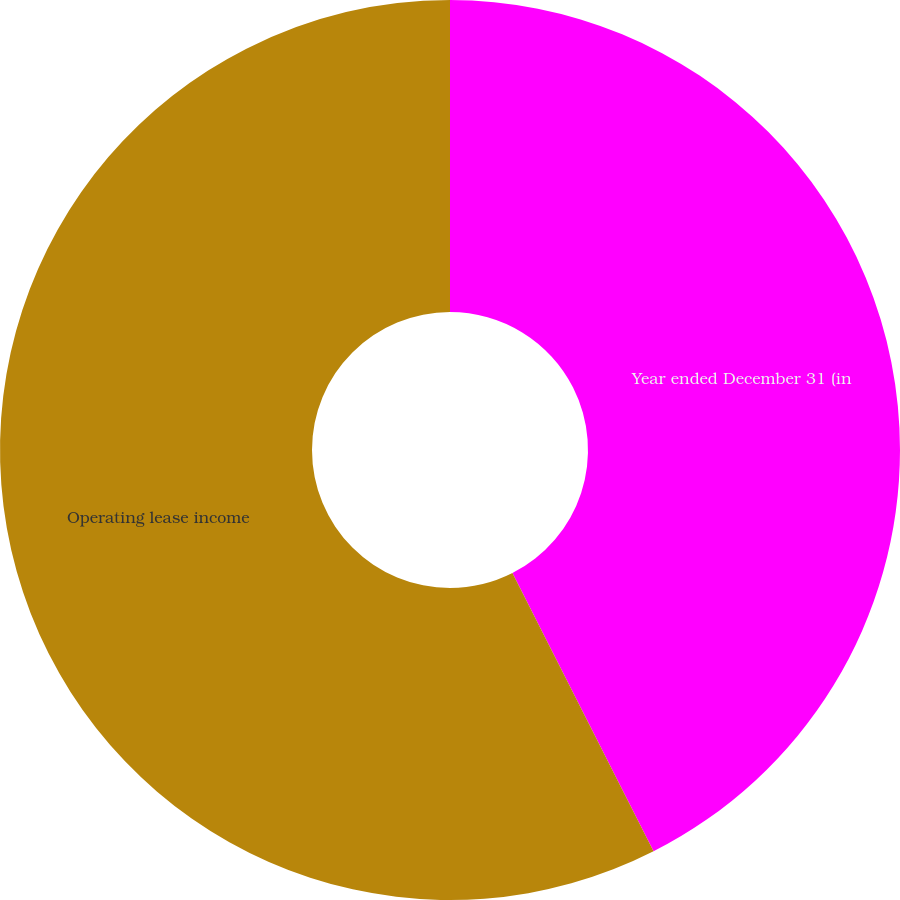Convert chart. <chart><loc_0><loc_0><loc_500><loc_500><pie_chart><fcel>Year ended December 31 (in<fcel>Operating lease income<nl><fcel>42.53%<fcel>57.47%<nl></chart> 